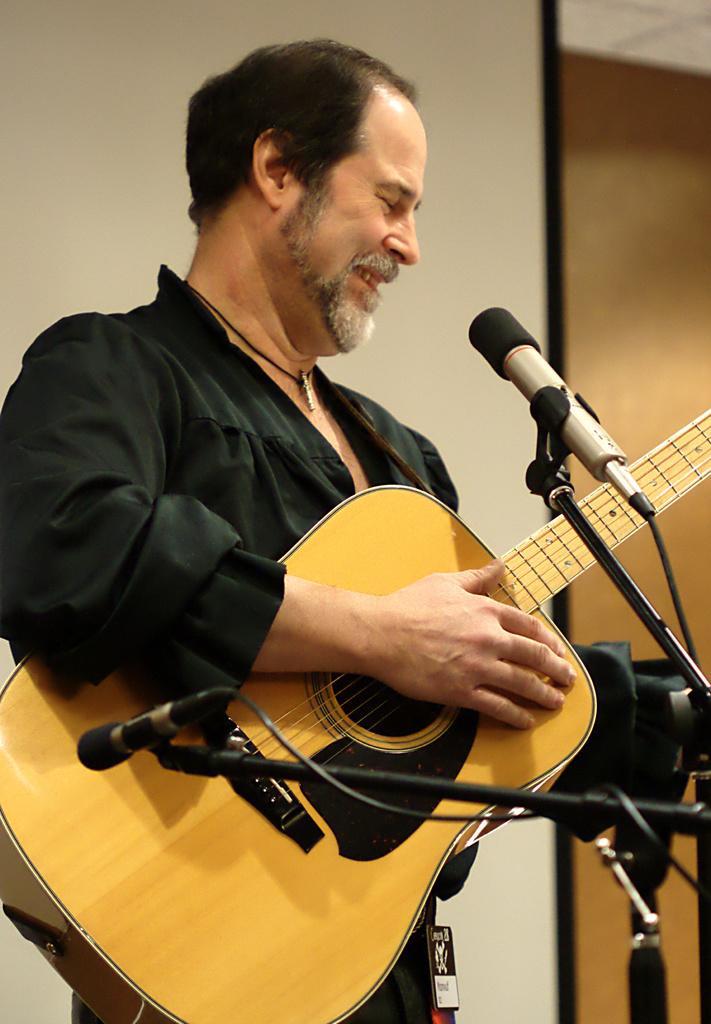In one or two sentences, can you explain what this image depicts? In this image, there is a person wearing clothes and playing a guitar. This person is standing in front of the two mics. There is a wall behind this person. 